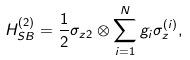<formula> <loc_0><loc_0><loc_500><loc_500>H _ { S B } ^ { ( 2 ) } = \frac { 1 } { 2 } \sigma _ { z 2 } \otimes \sum _ { i = 1 } ^ { N } g _ { i } \sigma _ { z } ^ { ( i ) } ,</formula> 